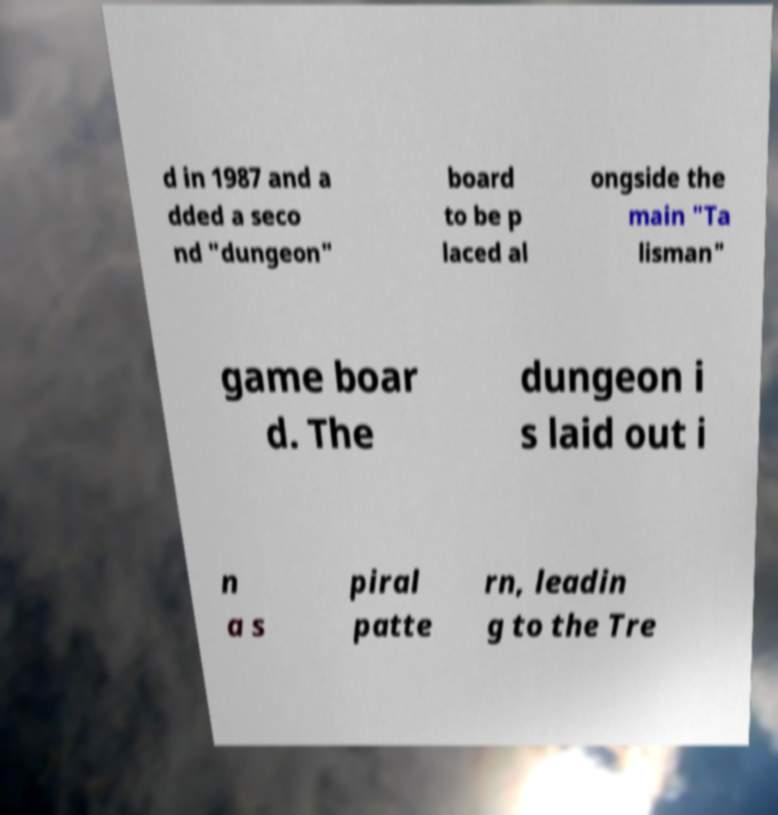Can you read and provide the text displayed in the image?This photo seems to have some interesting text. Can you extract and type it out for me? d in 1987 and a dded a seco nd "dungeon" board to be p laced al ongside the main "Ta lisman" game boar d. The dungeon i s laid out i n a s piral patte rn, leadin g to the Tre 